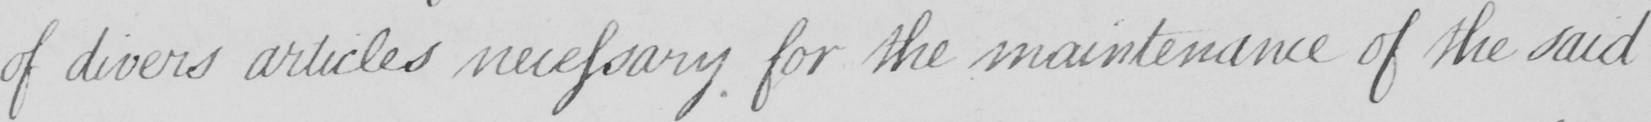Transcribe the text shown in this historical manuscript line. of divers articles necessary for the maintenance of the said 